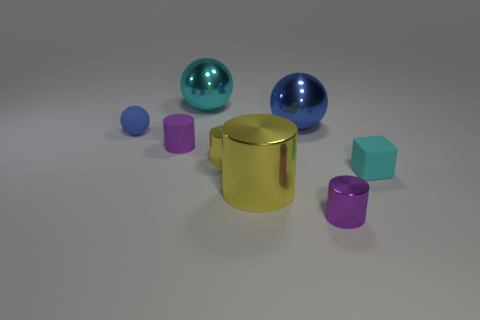Are there any small yellow shiny things of the same shape as the large blue metal thing?
Your response must be concise. No. The yellow metal object that is the same size as the cyan metallic thing is what shape?
Give a very brief answer. Cylinder. How many objects are behind the tiny cyan cube and in front of the cyan metallic thing?
Provide a short and direct response. 4. Are there fewer cyan objects that are behind the cyan rubber thing than tiny rubber blocks?
Offer a terse response. No. Is there a purple metal thing of the same size as the purple rubber cylinder?
Provide a succinct answer. Yes. The small ball that is the same material as the small block is what color?
Your answer should be very brief. Blue. There is a tiny shiny cylinder that is behind the cyan matte object; how many purple objects are right of it?
Provide a short and direct response. 1. What material is the thing that is both behind the purple rubber object and in front of the blue shiny ball?
Keep it short and to the point. Rubber. There is a cyan object that is in front of the tiny blue rubber sphere; is its shape the same as the cyan metallic thing?
Your answer should be very brief. No. Are there fewer small yellow shiny cylinders than big red objects?
Your response must be concise. No. 